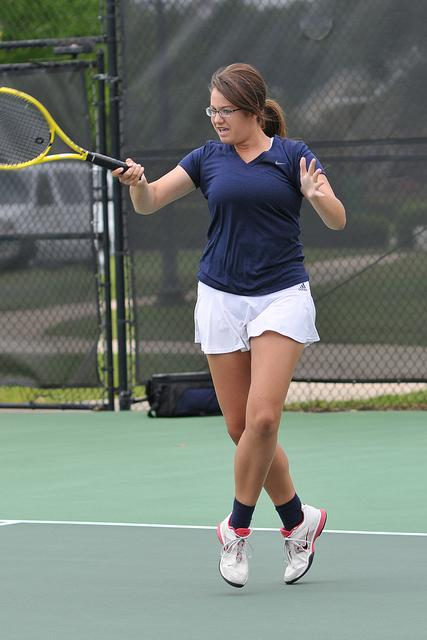What brand skirt she worn? Please explain your reasoning. adidas. There is an adidas logo on the skirt. 